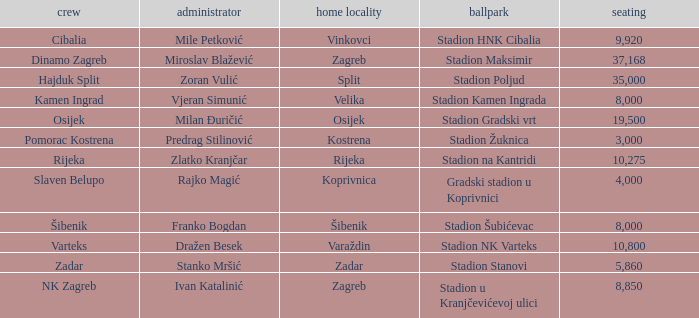Could you parse the entire table? {'header': ['crew', 'administrator', 'home locality', 'ballpark', 'seating'], 'rows': [['Cibalia', 'Mile Petković', 'Vinkovci', 'Stadion HNK Cibalia', '9,920'], ['Dinamo Zagreb', 'Miroslav Blažević', 'Zagreb', 'Stadion Maksimir', '37,168'], ['Hajduk Split', 'Zoran Vulić', 'Split', 'Stadion Poljud', '35,000'], ['Kamen Ingrad', 'Vjeran Simunić', 'Velika', 'Stadion Kamen Ingrada', '8,000'], ['Osijek', 'Milan Đuričić', 'Osijek', 'Stadion Gradski vrt', '19,500'], ['Pomorac Kostrena', 'Predrag Stilinović', 'Kostrena', 'Stadion Žuknica', '3,000'], ['Rijeka', 'Zlatko Kranjčar', 'Rijeka', 'Stadion na Kantridi', '10,275'], ['Slaven Belupo', 'Rajko Magić', 'Koprivnica', 'Gradski stadion u Koprivnici', '4,000'], ['Šibenik', 'Franko Bogdan', 'Šibenik', 'Stadion Šubićevac', '8,000'], ['Varteks', 'Dražen Besek', 'Varaždin', 'Stadion NK Varteks', '10,800'], ['Zadar', 'Stanko Mršić', 'Zadar', 'Stadion Stanovi', '5,860'], ['NK Zagreb', 'Ivan Katalinić', 'Zagreb', 'Stadion u Kranjčevićevoj ulici', '8,850']]} What team has a home city of Velika? Kamen Ingrad. 